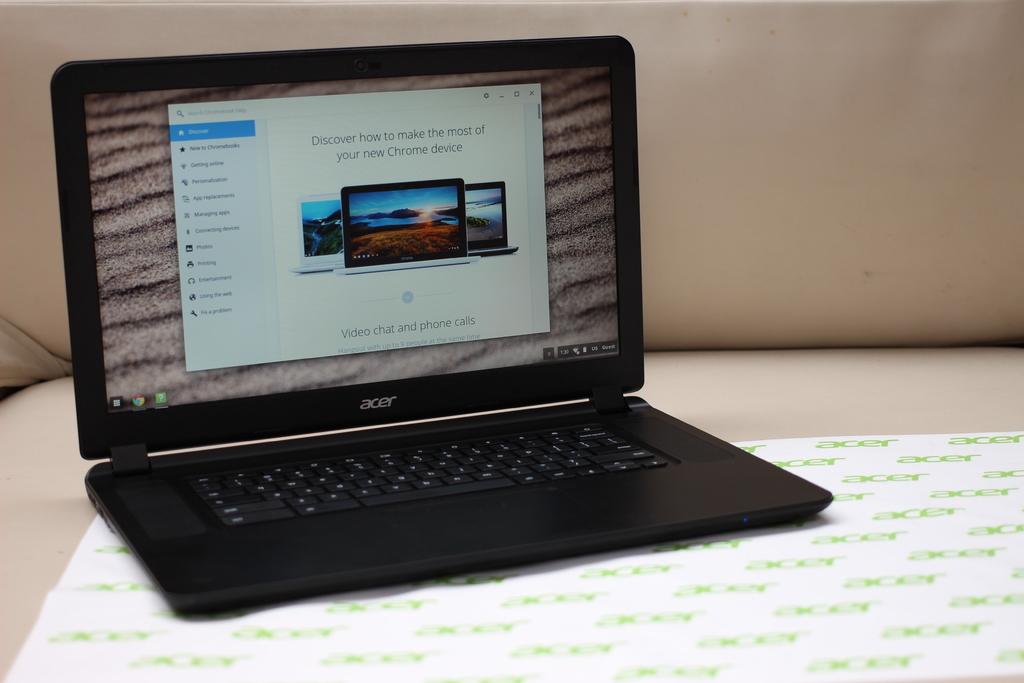What brand of computer is this?
Your response must be concise. Acer. 